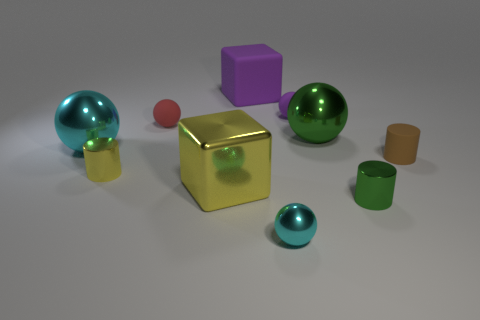Subtract all tiny metal cylinders. How many cylinders are left? 1 Subtract all red spheres. How many spheres are left? 4 Subtract all brown cubes. How many cyan balls are left? 2 Subtract 1 cylinders. How many cylinders are left? 2 Subtract all cylinders. How many objects are left? 7 Add 1 tiny cyan things. How many tiny cyan things are left? 2 Add 4 small metal balls. How many small metal balls exist? 5 Subtract 1 green spheres. How many objects are left? 9 Subtract all purple cubes. Subtract all blue cylinders. How many cubes are left? 1 Subtract all big metallic spheres. Subtract all small brown cylinders. How many objects are left? 7 